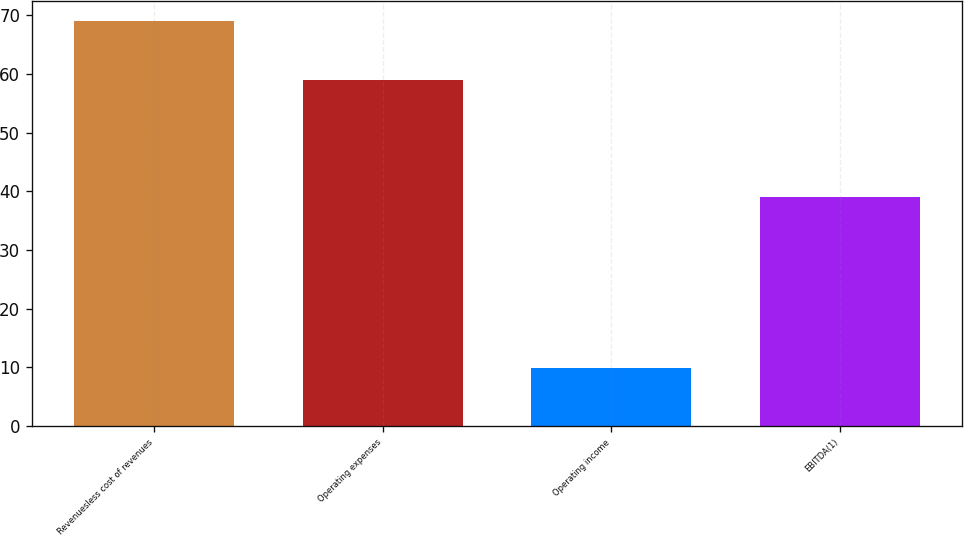<chart> <loc_0><loc_0><loc_500><loc_500><bar_chart><fcel>Revenuesless cost of revenues<fcel>Operating expenses<fcel>Operating income<fcel>EBITDA(1)<nl><fcel>69<fcel>59<fcel>9.9<fcel>39<nl></chart> 